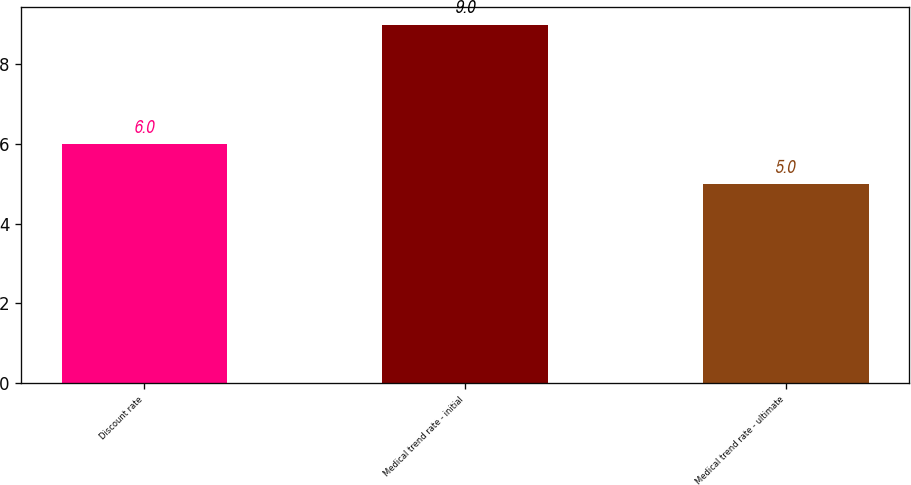<chart> <loc_0><loc_0><loc_500><loc_500><bar_chart><fcel>Discount rate<fcel>Medical trend rate - initial<fcel>Medical trend rate - ultimate<nl><fcel>6<fcel>9<fcel>5<nl></chart> 